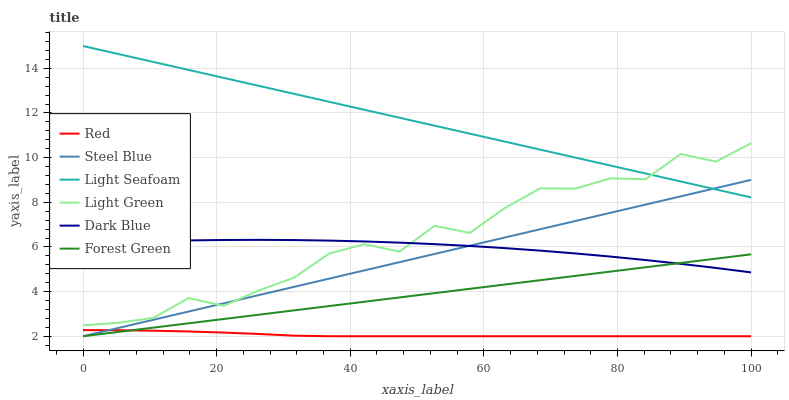Does Red have the minimum area under the curve?
Answer yes or no. Yes. Does Light Seafoam have the maximum area under the curve?
Answer yes or no. Yes. Does Dark Blue have the minimum area under the curve?
Answer yes or no. No. Does Dark Blue have the maximum area under the curve?
Answer yes or no. No. Is Forest Green the smoothest?
Answer yes or no. Yes. Is Light Green the roughest?
Answer yes or no. Yes. Is Dark Blue the smoothest?
Answer yes or no. No. Is Dark Blue the roughest?
Answer yes or no. No. Does Steel Blue have the lowest value?
Answer yes or no. Yes. Does Dark Blue have the lowest value?
Answer yes or no. No. Does Light Seafoam have the highest value?
Answer yes or no. Yes. Does Dark Blue have the highest value?
Answer yes or no. No. Is Red less than Light Green?
Answer yes or no. Yes. Is Light Seafoam greater than Dark Blue?
Answer yes or no. Yes. Does Dark Blue intersect Forest Green?
Answer yes or no. Yes. Is Dark Blue less than Forest Green?
Answer yes or no. No. Is Dark Blue greater than Forest Green?
Answer yes or no. No. Does Red intersect Light Green?
Answer yes or no. No. 